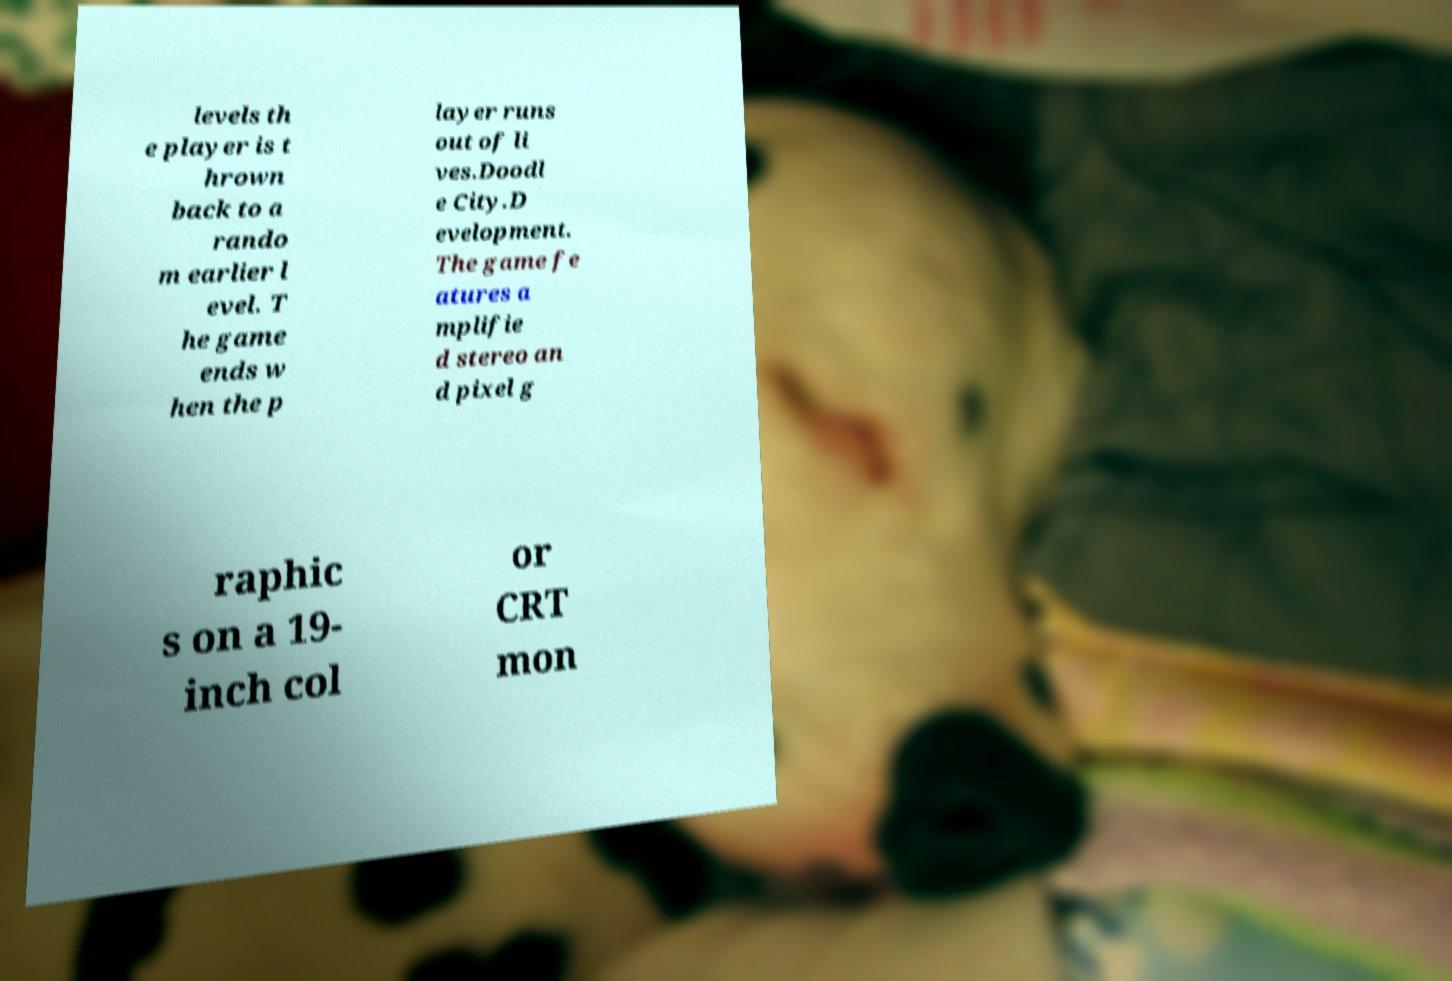I need the written content from this picture converted into text. Can you do that? levels th e player is t hrown back to a rando m earlier l evel. T he game ends w hen the p layer runs out of li ves.Doodl e City.D evelopment. The game fe atures a mplifie d stereo an d pixel g raphic s on a 19- inch col or CRT mon 